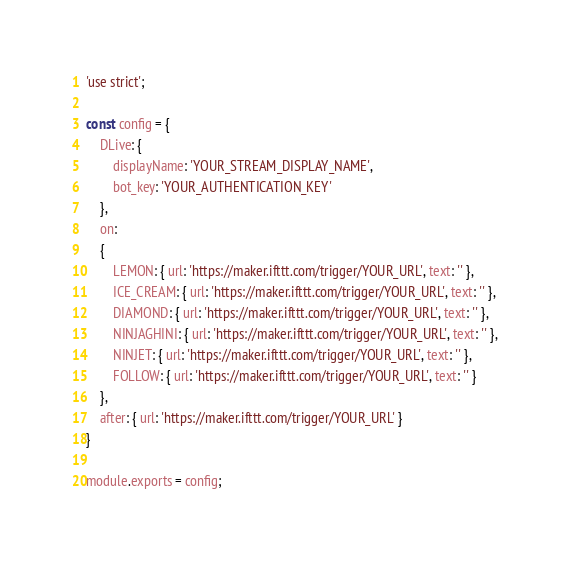<code> <loc_0><loc_0><loc_500><loc_500><_JavaScript_>'use strict';

const config = {
    DLive: {
        displayName: 'YOUR_STREAM_DISPLAY_NAME',
        bot_key: 'YOUR_AUTHENTICATION_KEY'
    },
    on:
    {
        LEMON: { url: 'https://maker.ifttt.com/trigger/YOUR_URL', text: '' },
        ICE_CREAM: { url: 'https://maker.ifttt.com/trigger/YOUR_URL', text: '' },
        DIAMOND: { url: 'https://maker.ifttt.com/trigger/YOUR_URL', text: '' },
        NINJAGHINI: { url: 'https://maker.ifttt.com/trigger/YOUR_URL', text: '' },
        NINJET: { url: 'https://maker.ifttt.com/trigger/YOUR_URL', text: '' },
        FOLLOW: { url: 'https://maker.ifttt.com/trigger/YOUR_URL', text: '' }
    },
    after: { url: 'https://maker.ifttt.com/trigger/YOUR_URL' }
}

module.exports = config;</code> 